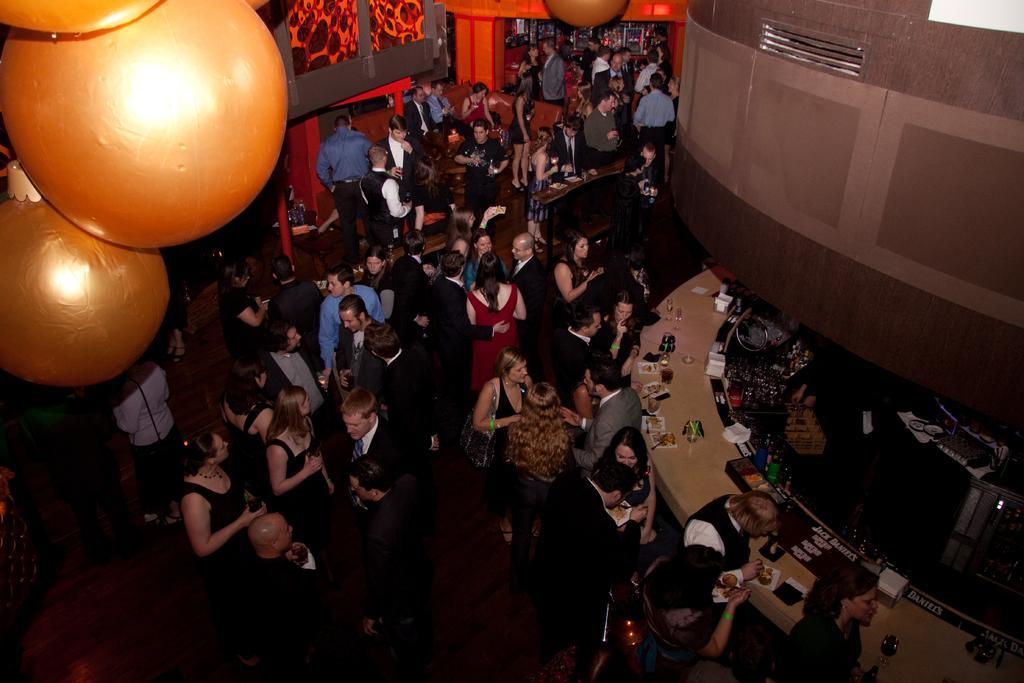Can you describe this image briefly? This image is taken from the top, where we can see a group of people standing and a few of them are standing in front of a table which contains many objects on it, on the top left corner there are some objects which looks like lights. 